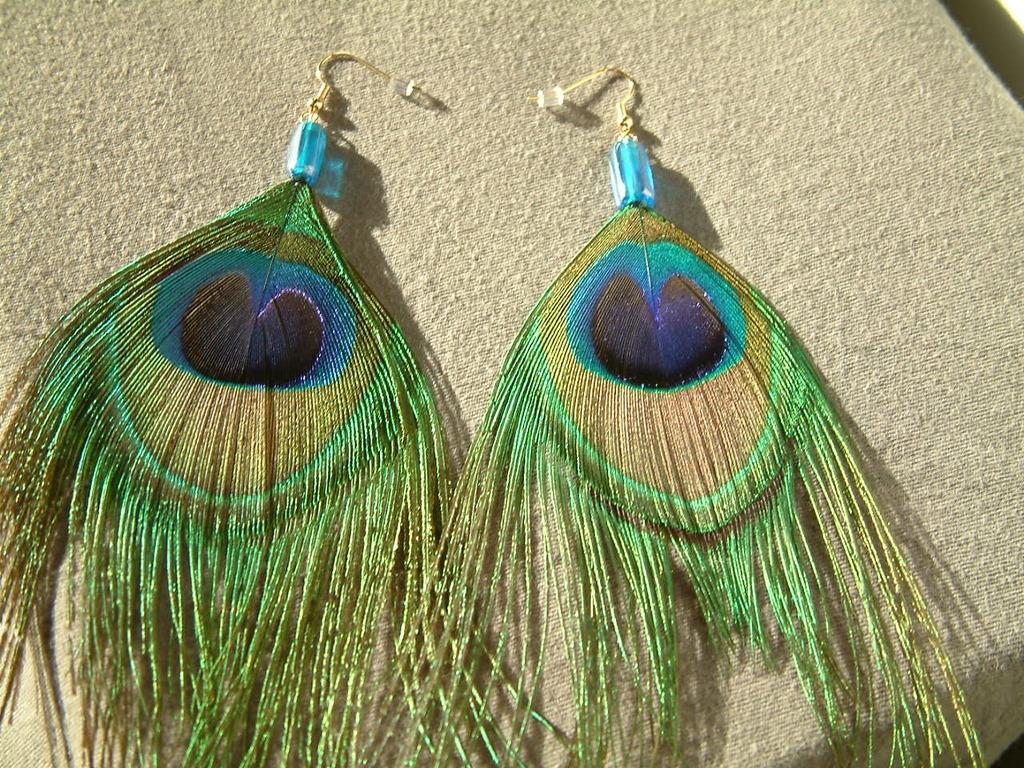Could you give a brief overview of what you see in this image? In this image we can see a pair of earrings on the surface. 